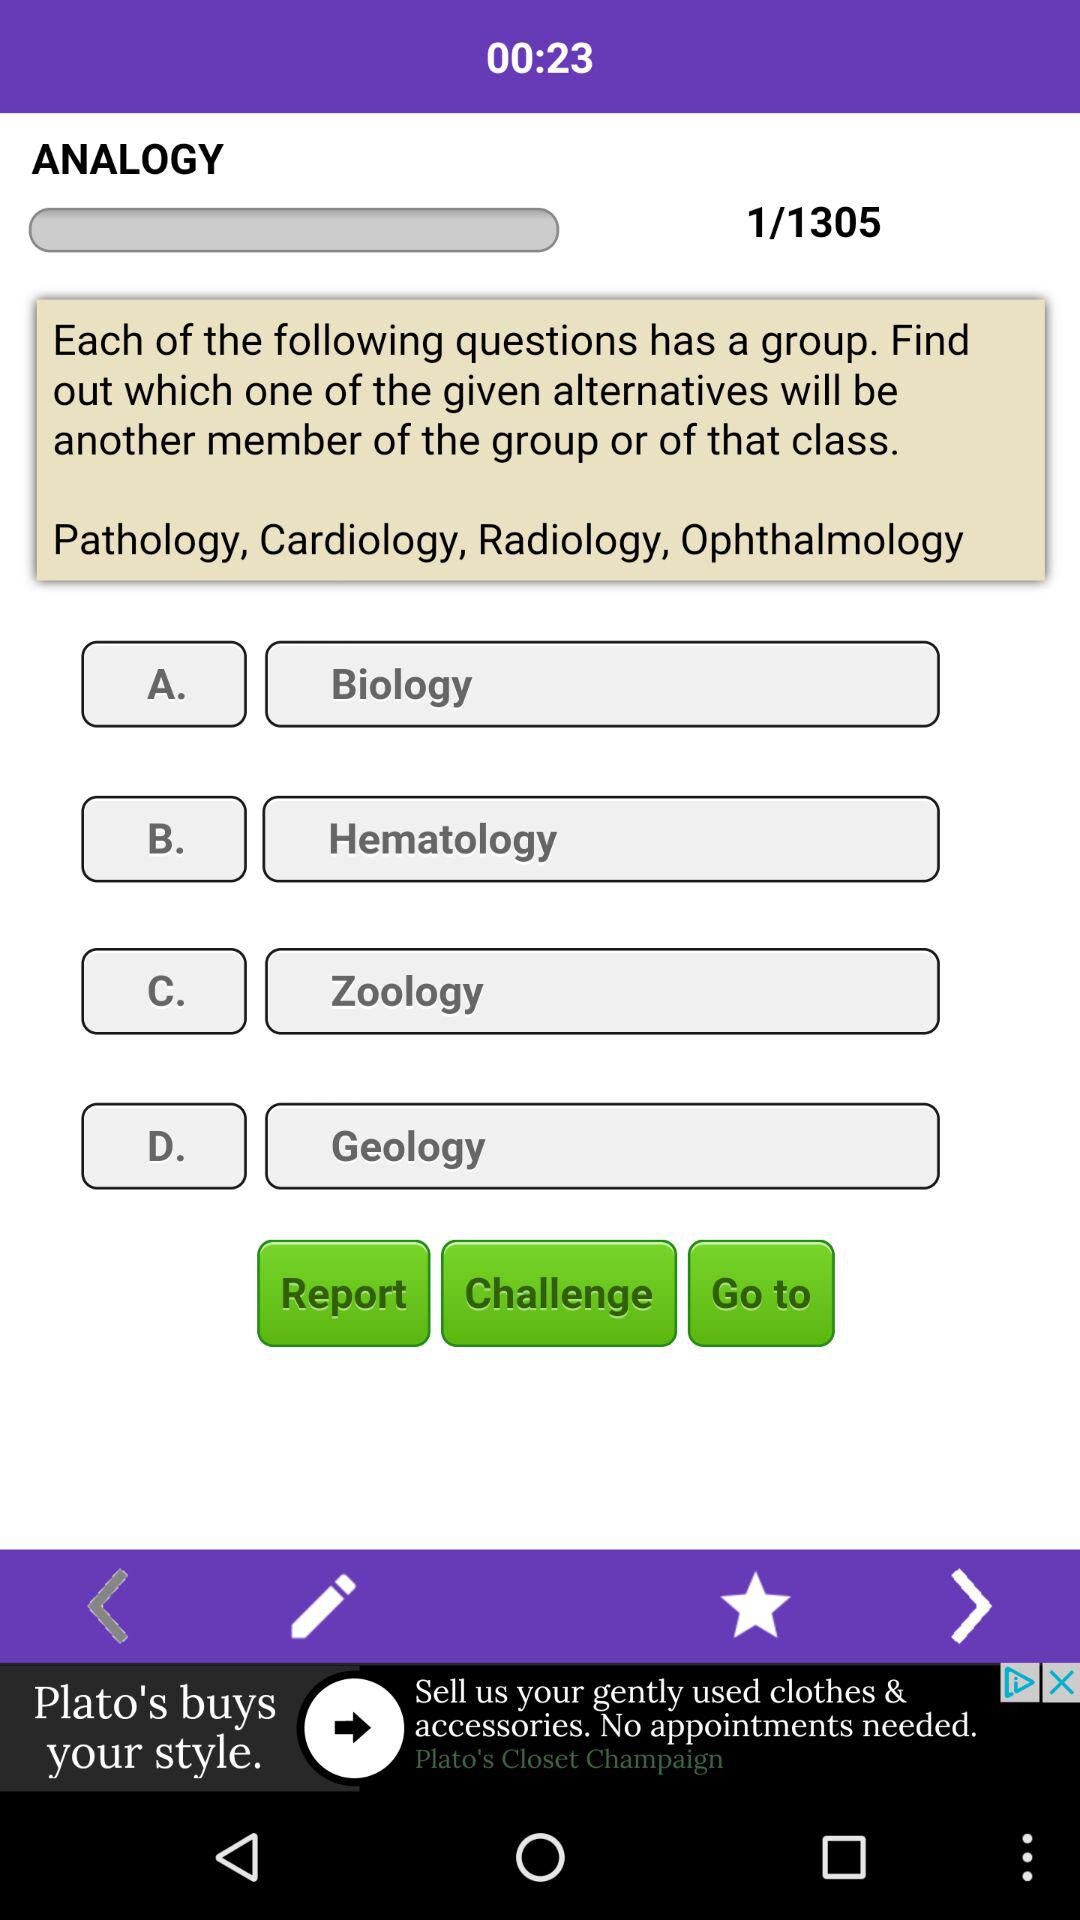What is the remaining time displayed on the screen? The remaining time displayed on the screen is 23 seconds. 